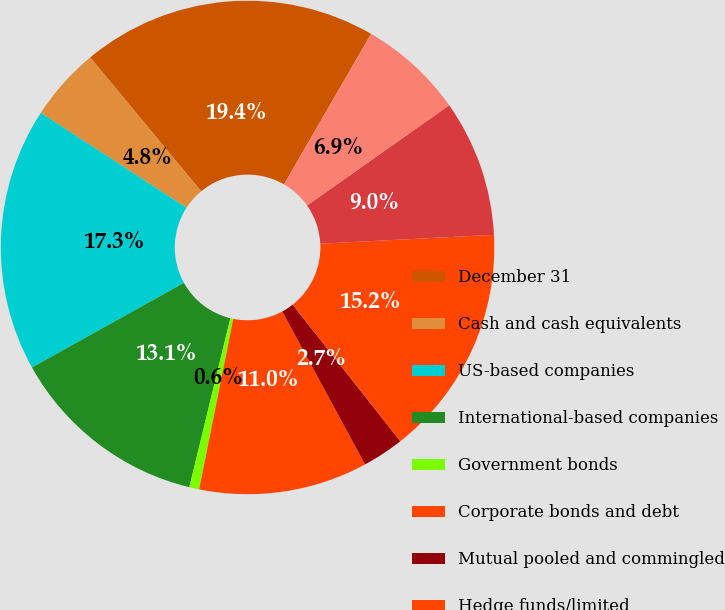Convert chart. <chart><loc_0><loc_0><loc_500><loc_500><pie_chart><fcel>December 31<fcel>Cash and cash equivalents<fcel>US-based companies<fcel>International-based companies<fcel>Government bonds<fcel>Corporate bonds and debt<fcel>Mutual pooled and commingled<fcel>Hedge funds/limited<fcel>Real estate<fcel>Other<nl><fcel>19.35%<fcel>4.81%<fcel>17.27%<fcel>13.12%<fcel>0.65%<fcel>11.04%<fcel>2.73%<fcel>15.19%<fcel>8.96%<fcel>6.88%<nl></chart> 